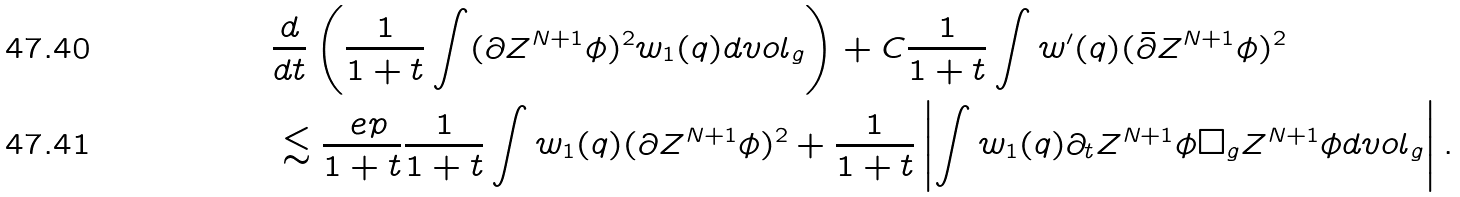<formula> <loc_0><loc_0><loc_500><loc_500>& \frac { d } { d t } \left ( \frac { 1 } { 1 + t } \int ( \partial Z ^ { N + 1 } \phi ) ^ { 2 } w _ { 1 } ( q ) d v o l _ { g } \right ) + C \frac { 1 } { 1 + t } \int w ^ { \prime } ( q ) ( \bar { \partial } Z ^ { N + 1 } \phi ) ^ { 2 } \\ & \lesssim \frac { \ e p } { 1 + t } \frac { 1 } { 1 + t } \int w _ { 1 } ( q ) ( \partial Z ^ { N + 1 } \phi ) ^ { 2 } + \frac { 1 } { 1 + t } \left | \int w _ { 1 } ( q ) \partial _ { t } Z ^ { N + 1 } \phi \Box _ { g } Z ^ { N + 1 } \phi d v o l _ { g } \right | .</formula> 